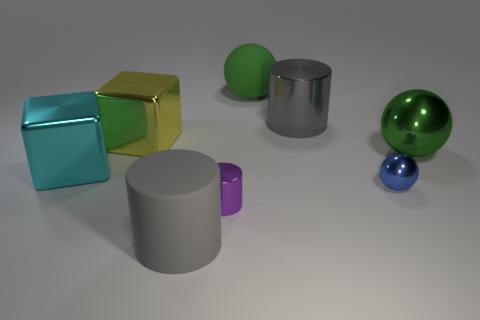Are there fewer tiny yellow things than blue metallic spheres?
Make the answer very short. Yes. How many purple things are either metallic spheres or tiny spheres?
Offer a terse response. 0. What number of things are both left of the blue metal thing and behind the big rubber cylinder?
Your response must be concise. 5. Are the big cyan block and the yellow thing made of the same material?
Offer a very short reply. Yes. There is a cyan thing that is the same size as the rubber sphere; what is its shape?
Provide a succinct answer. Cube. Is the number of green matte things greater than the number of red cylinders?
Offer a terse response. Yes. There is a thing that is on the right side of the small shiny cylinder and on the left side of the gray shiny object; what material is it made of?
Provide a succinct answer. Rubber. How many other things are the same material as the purple thing?
Make the answer very short. 5. What number of objects have the same color as the rubber cylinder?
Give a very brief answer. 1. There is a green sphere behind the large cylinder that is right of the large gray cylinder that is in front of the big gray metal object; what size is it?
Make the answer very short. Large. 